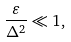<formula> <loc_0><loc_0><loc_500><loc_500>\frac { \varepsilon } { { \Delta } ^ { 2 } } \ll 1 ,</formula> 